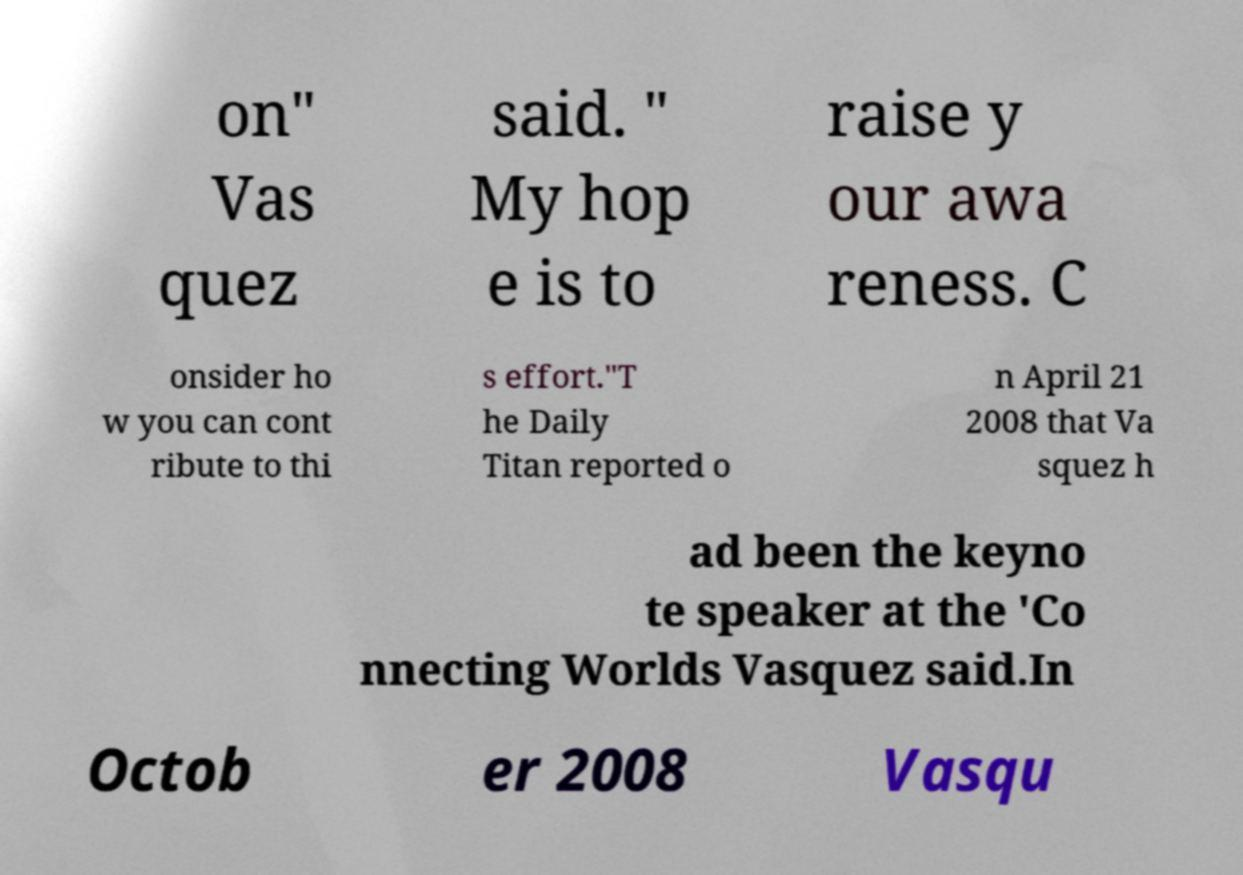Please identify and transcribe the text found in this image. on" Vas quez said. " My hop e is to raise y our awa reness. C onsider ho w you can cont ribute to thi s effort."T he Daily Titan reported o n April 21 2008 that Va squez h ad been the keyno te speaker at the 'Co nnecting Worlds Vasquez said.In Octob er 2008 Vasqu 